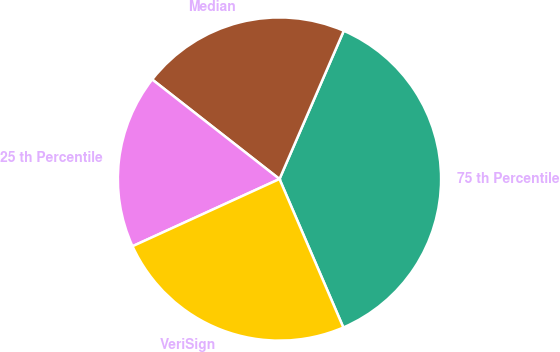<chart> <loc_0><loc_0><loc_500><loc_500><pie_chart><fcel>75 th Percentile<fcel>Median<fcel>25 th Percentile<fcel>VeriSign<nl><fcel>37.02%<fcel>20.95%<fcel>17.39%<fcel>24.64%<nl></chart> 